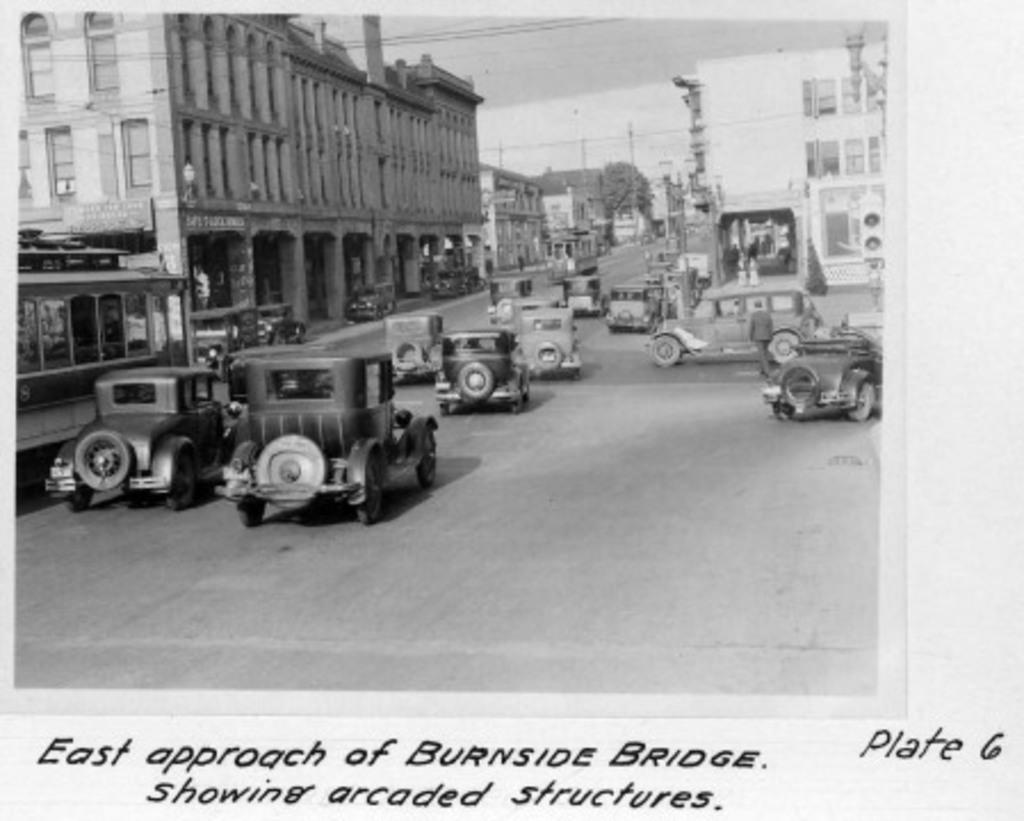Describe this image in one or two sentences. This is an edited image with the borders and the picture is clicked outside. On the right we can see the group of vehicles and in the center we can see the buildings and we can see the text on the boards. In the background we can see the sky, cables, trees and many other objects and we can see the text on the image. 